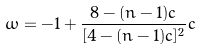Convert formula to latex. <formula><loc_0><loc_0><loc_500><loc_500>\omega = - 1 + \frac { 8 - ( n - 1 ) c } { [ 4 - ( n - 1 ) c ] ^ { 2 } } c</formula> 